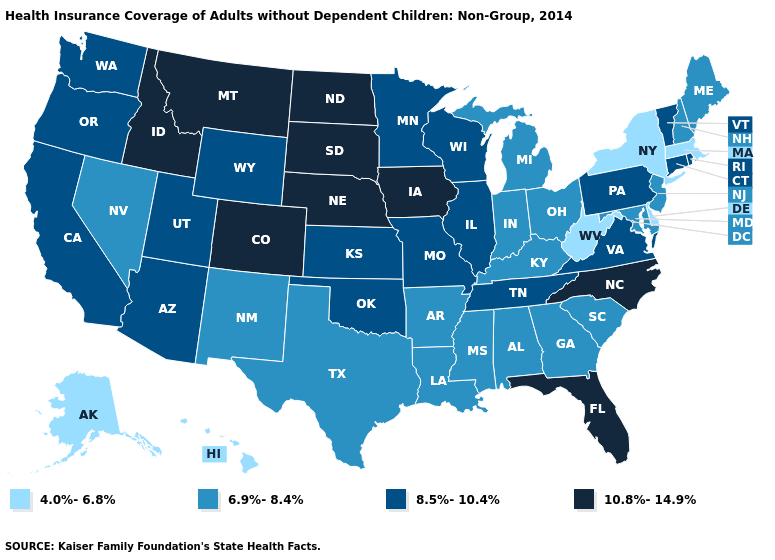Name the states that have a value in the range 4.0%-6.8%?
Give a very brief answer. Alaska, Delaware, Hawaii, Massachusetts, New York, West Virginia. What is the lowest value in states that border Ohio?
Answer briefly. 4.0%-6.8%. Name the states that have a value in the range 4.0%-6.8%?
Keep it brief. Alaska, Delaware, Hawaii, Massachusetts, New York, West Virginia. Does Rhode Island have the lowest value in the USA?
Answer briefly. No. Name the states that have a value in the range 10.8%-14.9%?
Be succinct. Colorado, Florida, Idaho, Iowa, Montana, Nebraska, North Carolina, North Dakota, South Dakota. Which states hav the highest value in the South?
Answer briefly. Florida, North Carolina. What is the value of North Carolina?
Answer briefly. 10.8%-14.9%. Does Rhode Island have the lowest value in the Northeast?
Quick response, please. No. What is the value of Washington?
Short answer required. 8.5%-10.4%. What is the value of Montana?
Be succinct. 10.8%-14.9%. Name the states that have a value in the range 4.0%-6.8%?
Concise answer only. Alaska, Delaware, Hawaii, Massachusetts, New York, West Virginia. Name the states that have a value in the range 6.9%-8.4%?
Be succinct. Alabama, Arkansas, Georgia, Indiana, Kentucky, Louisiana, Maine, Maryland, Michigan, Mississippi, Nevada, New Hampshire, New Jersey, New Mexico, Ohio, South Carolina, Texas. Which states hav the highest value in the MidWest?
Give a very brief answer. Iowa, Nebraska, North Dakota, South Dakota. Does the map have missing data?
Be succinct. No. Does the map have missing data?
Keep it brief. No. 